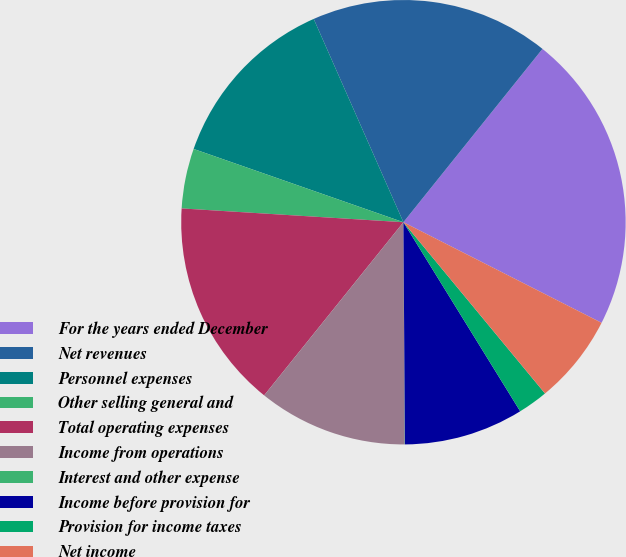<chart> <loc_0><loc_0><loc_500><loc_500><pie_chart><fcel>For the years ended December<fcel>Net revenues<fcel>Personnel expenses<fcel>Other selling general and<fcel>Total operating expenses<fcel>Income from operations<fcel>Interest and other expense<fcel>Income before provision for<fcel>Provision for income taxes<fcel>Net income<nl><fcel>21.72%<fcel>17.38%<fcel>13.04%<fcel>4.36%<fcel>15.21%<fcel>10.87%<fcel>0.02%<fcel>8.7%<fcel>2.19%<fcel>6.53%<nl></chart> 